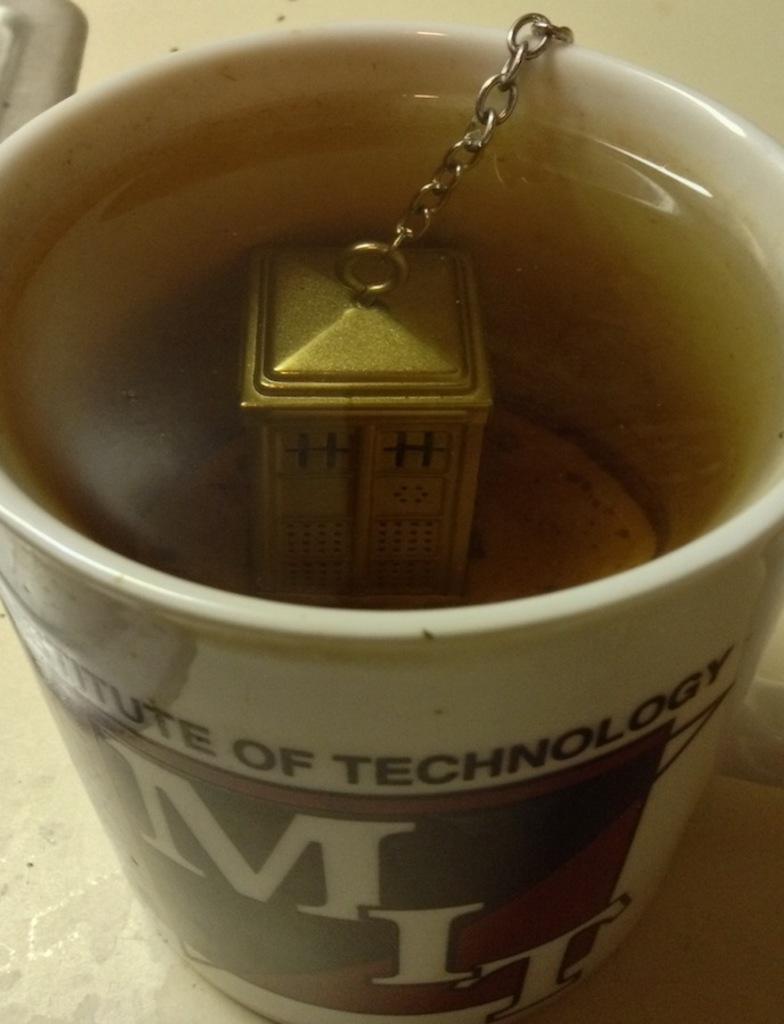What school is this mug from?
Provide a succinct answer. Mit. What is the initials on the mug?
Your response must be concise. Mit. 